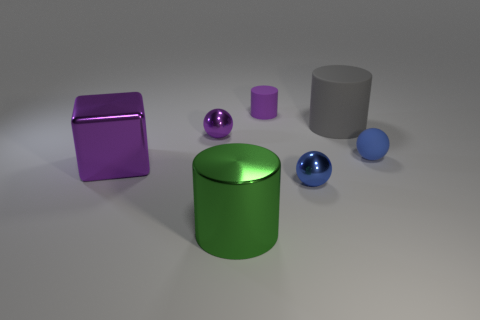Are there the same number of large things that are on the right side of the large purple shiny block and large purple shiny things? No, there are not. On the right side of the large purple shiny block, there are three objects: a large green cylinder, a small purple cylinder, and a small blue sphere. But if we consider just the large purple shiny things, there is only one, which is the large purple block itself. Therefore, the quantity of large objects on the right side of the purple block exceeds the number of large purple shiny objects. 